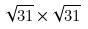Convert formula to latex. <formula><loc_0><loc_0><loc_500><loc_500>\sqrt { 3 1 } \times \sqrt { 3 1 }</formula> 